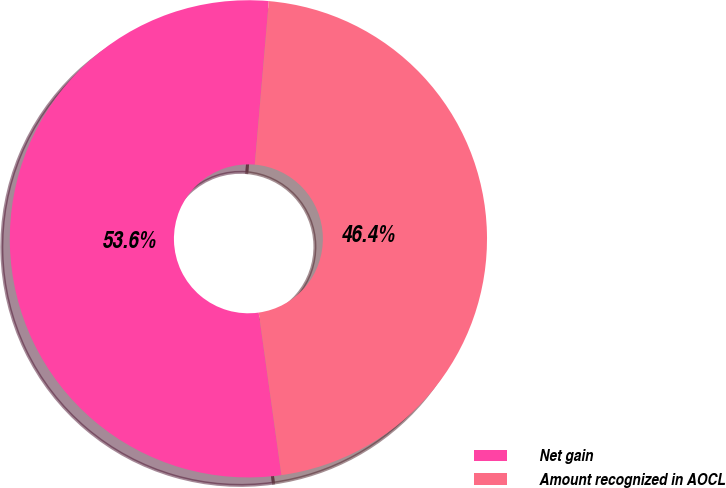Convert chart. <chart><loc_0><loc_0><loc_500><loc_500><pie_chart><fcel>Net gain<fcel>Amount recognized in AOCL<nl><fcel>53.57%<fcel>46.43%<nl></chart> 